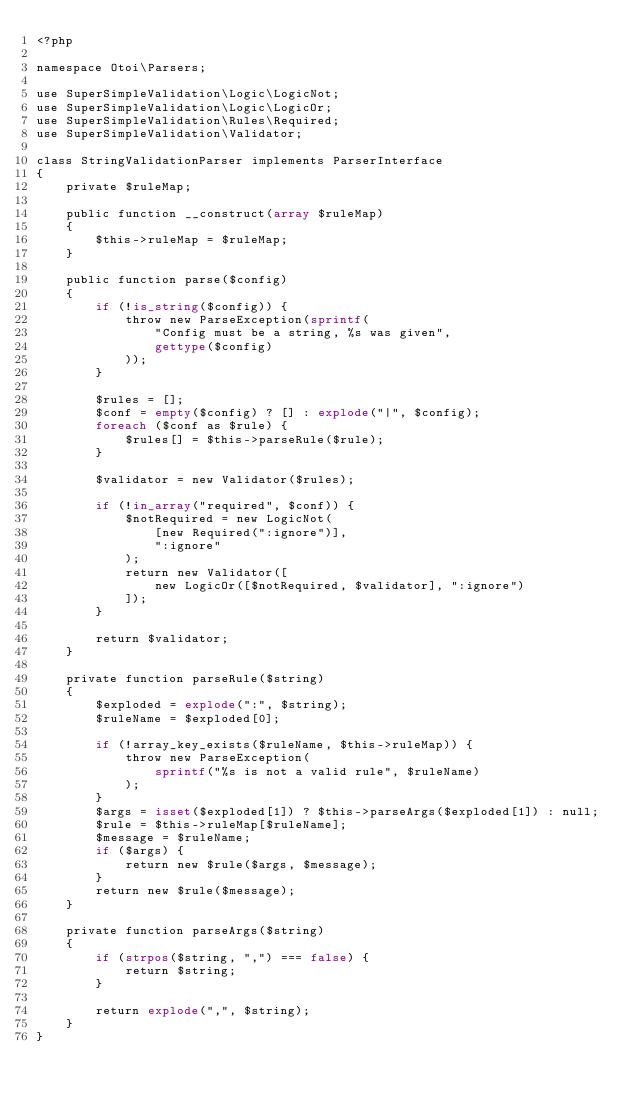Convert code to text. <code><loc_0><loc_0><loc_500><loc_500><_PHP_><?php

namespace Otoi\Parsers;

use SuperSimpleValidation\Logic\LogicNot;
use SuperSimpleValidation\Logic\LogicOr;
use SuperSimpleValidation\Rules\Required;
use SuperSimpleValidation\Validator;

class StringValidationParser implements ParserInterface
{
    private $ruleMap;

    public function __construct(array $ruleMap)
    {
        $this->ruleMap = $ruleMap;
    }

    public function parse($config)
    {
        if (!is_string($config)) {
            throw new ParseException(sprintf(
                "Config must be a string, %s was given",
                gettype($config)
            ));
        }

        $rules = [];
        $conf = empty($config) ? [] : explode("|", $config);
        foreach ($conf as $rule) {
            $rules[] = $this->parseRule($rule);
        }

        $validator = new Validator($rules);

        if (!in_array("required", $conf)) {
            $notRequired = new LogicNot(
                [new Required(":ignore")],
                ":ignore"
            );
            return new Validator([
                new LogicOr([$notRequired, $validator], ":ignore")
            ]);
        }

        return $validator;
    }

    private function parseRule($string)
    {
        $exploded = explode(":", $string);
        $ruleName = $exploded[0];

        if (!array_key_exists($ruleName, $this->ruleMap)) {
            throw new ParseException(
                sprintf("%s is not a valid rule", $ruleName)
            );
        }
        $args = isset($exploded[1]) ? $this->parseArgs($exploded[1]) : null;
        $rule = $this->ruleMap[$ruleName];
        $message = $ruleName;
        if ($args) {
            return new $rule($args, $message);
        }
        return new $rule($message);
    }

    private function parseArgs($string)
    {
        if (strpos($string, ",") === false) {
            return $string;
        }

        return explode(",", $string);
    }
}</code> 